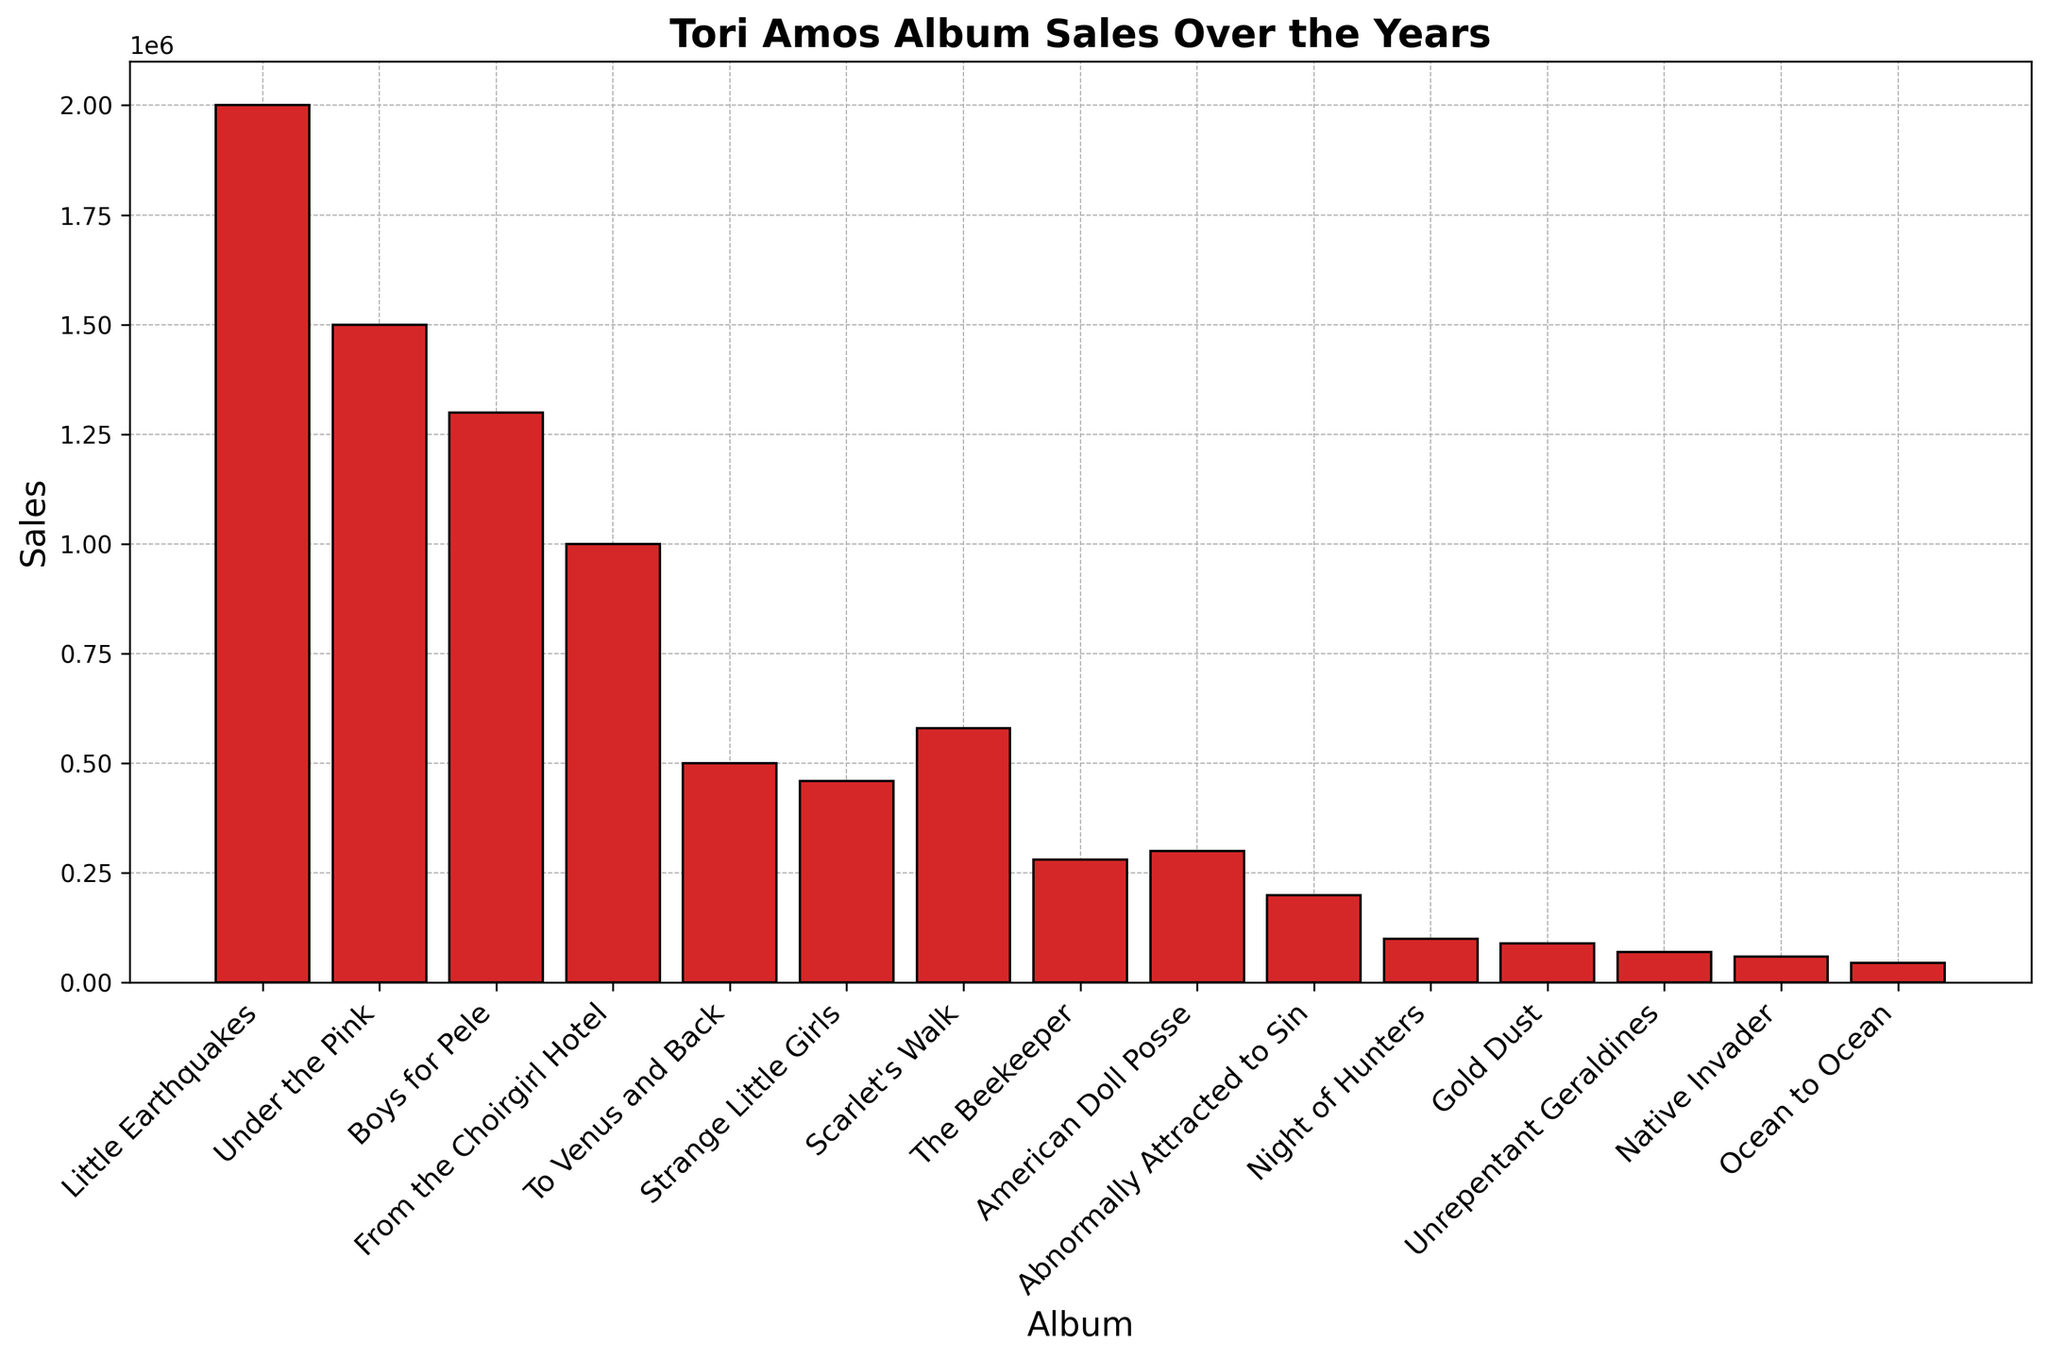What year had the highest album sales for Tori Amos? The highest album sales are represented by the tallest bar. The tallest bar corresponds to "Little Earthquakes," which was released in 1992.
Answer: 1992 Which Tori Amos album has the lowest sales, and what is its sales figure? The shortest bar on the chart indicates the lowest sales. "Ocean to Ocean" is represented by the shortest bar, with sales of 45,000 copies.
Answer: Ocean to Ocean, 45,000 How do the sales of "Boys for Pele" compare to "From the Choirgirl Hotel"? The bar for "Boys for Pele" is taller than the bar for "From the Choirgirl Hotel." Therefore, "Boys for Pele" has higher sales.
Answer: Boys for Pele has higher sales What is the total sales figure for albums released after 2010? Add the sales figures for albums released after 2010: "Night of Hunters" (100,000) + "Gold Dust" (90,000) + "Unrepentant Geraldines" (70,000) + "Native Invader" (60,000) + "Ocean to Ocean" (45,000). Total = 100,000 + 90,000 + 70,000 + 60,000 + 45,000 = 365,000.
Answer: 365,000 Compare the sales of "Scarlet's Walk" and "The Beekeeper." The bar for "Scarlet's Walk" is taller than the bar for "The Beekeeper." Therefore, "Scarlet's Walk" has higher sales.
Answer: Scarlet's Walk has higher sales What is the difference in sales between "Under the Pink" and "To Venus and Back"? Subtract the sales of "To Venus and Back" (500,000) from "Under the Pink" (1,500,000). 1,500,000 - 500,000 = 1,000,000.
Answer: 1,000,000 What is the average sales figure for the albums? Sum the sales figures for all albums and divide by the number of albums. Total sales = 2000000 + 1500000 + 1300000 + 1000000 + 500000 + 460000 + 580000 + 280000 + 300000 + 200000 + 100000 + 90000 + 70000 + 60000 + 45000 = 8700000. Number of albums = 15. Average = 8700000 / 15 = 580,000.
Answer: 580,000 Which decade saw the highest cumulative sales for Tori Amos albums? Sum the sales for albums in each decade. 1990s: 2000000 + 1500000 + 1300000 + 1000000 + 500000 = 6300000. 2000s: 460000 + 580000 + 280000 + 300000 + 200000 = 1820000. 2010s: 100000 + 90000 + 70000 + 60000 + 45000 = 365000. The 1990s have the highest cumulative sales.
Answer: 1990s 